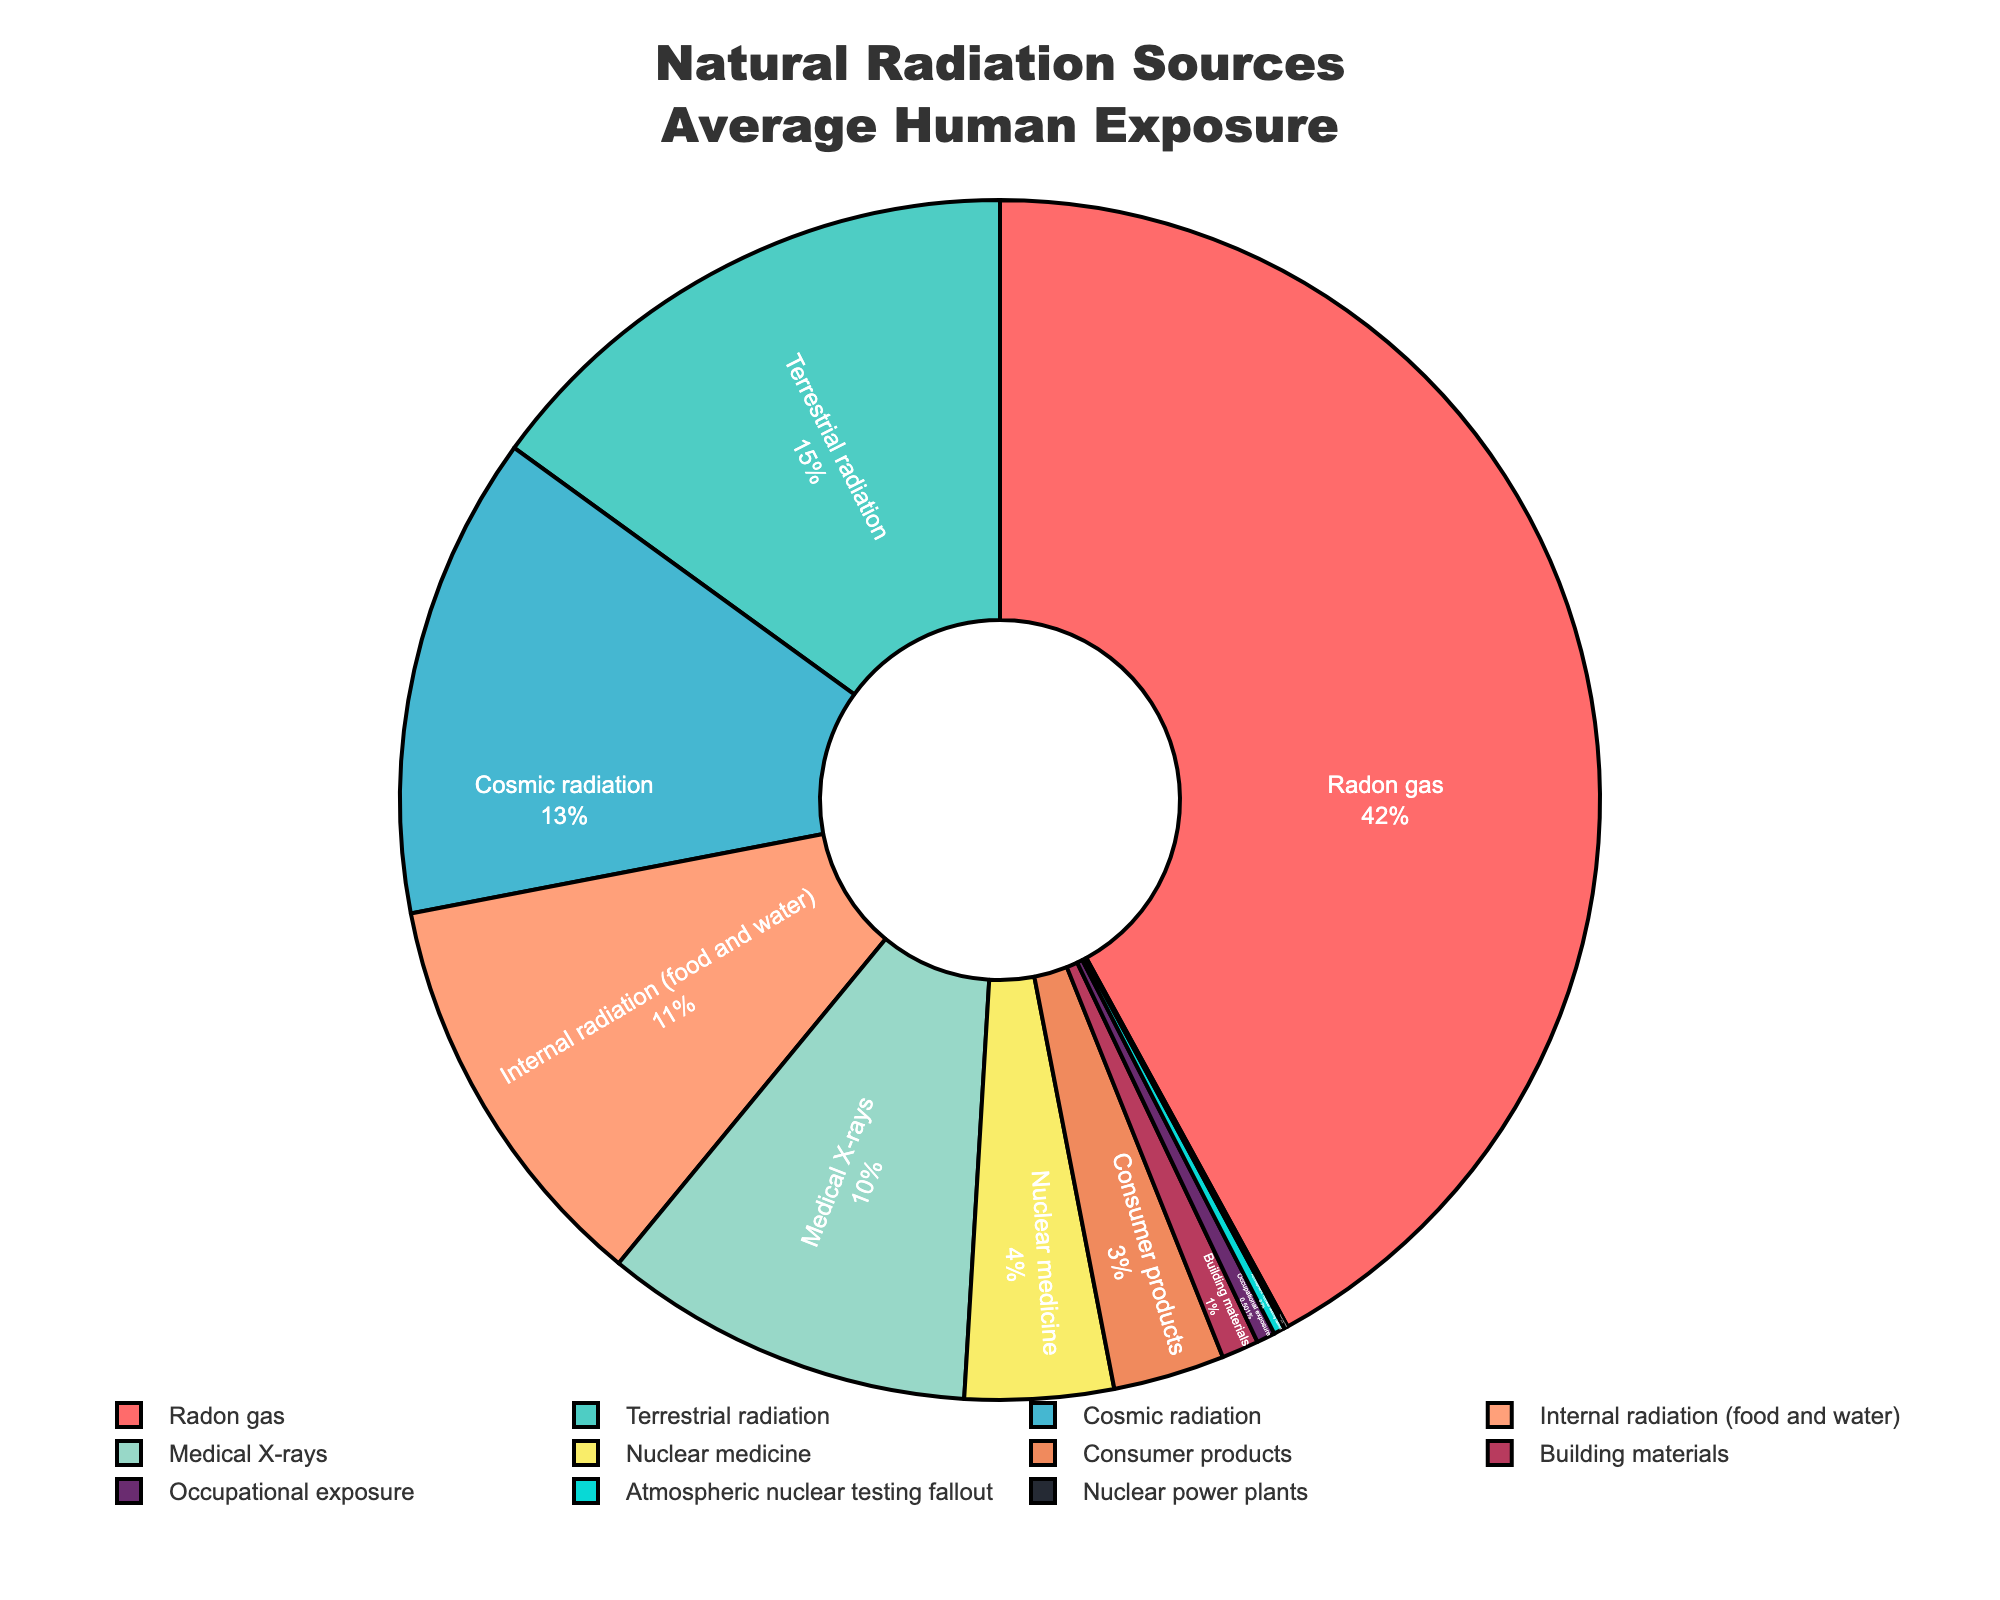What is the largest contributor to average human radiation exposure? The pie chart shows that "Radon gas" has the largest section, indicating it contributes the most to average human radiation exposure.
Answer: Radon gas What is the combined percentage contribution of cosmic and terrestrial radiation? Cosmic radiation contribution is 13% and terrestrial radiation contribution is 15%. Adding these together: 13% + 15% = 28%.
Answer: 28% Which source has the smallest contribution to average human radiation exposure? The pie chart indicates that "Nuclear power plants" has the smallest section with a contribution of 0.1%.
Answer: Nuclear power plants How does the contribution of consumer products compare to that of nuclear medicine? Consumer products contribute 3% while nuclear medicine contributes 4%. Thus, nuclear medicine contributes more than consumer products.
Answer: Nuclear medicine contributes more What is the total contribution of sources contributing less than 1% each? Sources contributing less than 1% are Nuclear power plants (0.1%), Atmospheric nuclear testing fallout (0.3%), and Occupational exposure (0.5%), and Building materials (1%). Summing these: 0.1% + 0.3% + 0.5% +1%= 1.9%.
Answer: 1.9% Which radiation sources are represented by colors on the red spectrum? Colors like '#FF6B6B' (Radon gas) and '#FFA07A' (Internal radiation) are red spectrum colors as seen in the pie chart.
Answer: Radon gas, Internal radiation (food and water) What is the difference in percentage between the largest and smallest contributors to radiation exposure? Radon gas contributes 42%, and Nuclear power plants contribute 0.1%. The difference is 42% - 0.1% = 41.9%.
Answer: 41.9% Are there more sources that contribute over or under 10% to average human radiation exposure? Sources contributing over 10% are Radon gas (42%), Cosmic radiation (13%), Terrestrial radiation (15%), and Internal radiation (11%) which are 4 sources. Sources contributing under 10% are 7 sources.
Answer: More sources contribute under 10% What percentage of radiation exposure is due to medical-related sources? Medical X-rays contribute 10% and Nuclear medicine contributes 4%. Adding these together: 10% + 4% = 14%.
Answer: 14% How much higher is the percentage contribution of radon gas compared to medical X-rays? Radon gas contributes 42%, and Medical X-rays contribute 10%. Subtracting these: 42% - 10% = 32%.
Answer: 32% 